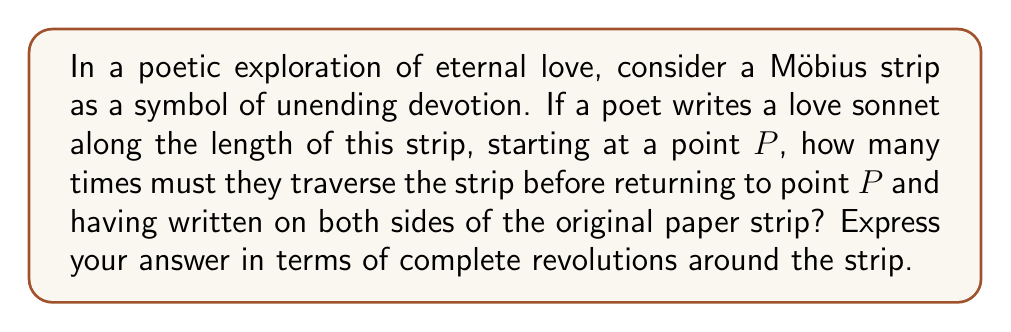What is the answer to this math problem? To understand this problem, we need to consider the unique topological properties of a Möbius strip:

1. A Möbius strip is a non-orientable surface with only one side and one edge.

2. It is created by taking a rectangular strip of paper and giving it a half-twist before joining the ends.

Now, let's analyze the poet's journey:

1. The poet starts writing at point $P$ on what appears to be one side of the strip.

2. As they move along the length of the strip, they will eventually reach the "twist" in the Möbius strip.

3. After passing the twist, they will find themselves writing on what appears to be the "other side" of the original strip.

4. When they complete one full revolution around the strip, they will return to point $P$, but will be on the "opposite" side from where they started.

5. To return to point $P$ on the "same" side and have written on both apparent sides of the original strip, they need to make one more complete revolution.

Therefore, the poet must traverse the entire length of the Möbius strip twice, which is equivalent to two complete revolutions around the strip.

This process can be represented mathematically as follows:

Let $L$ be the length of the Möbius strip.
The total distance traveled by the poet is $2L$.
The number of revolutions is given by:

$$ \text{Number of revolutions} = \frac{\text{Total distance traveled}}{\text{Length of strip}} = \frac{2L}{L} = 2 $$

This result beautifully aligns with the concept of eternal love, as the poet's words seamlessly flow from one "side" to the other, creating a continuous, never-ending loop of devotion.
Answer: 2 revolutions 